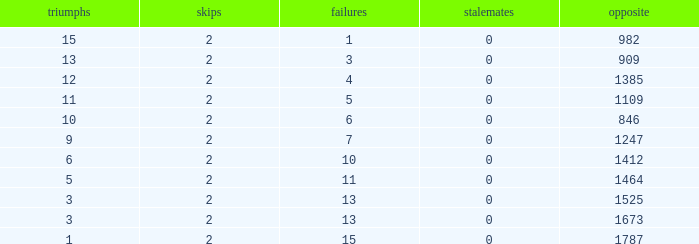What is the number listed under against when there were less than 13 losses and less than 2 byes? 0.0. Write the full table. {'header': ['triumphs', 'skips', 'failures', 'stalemates', 'opposite'], 'rows': [['15', '2', '1', '0', '982'], ['13', '2', '3', '0', '909'], ['12', '2', '4', '0', '1385'], ['11', '2', '5', '0', '1109'], ['10', '2', '6', '0', '846'], ['9', '2', '7', '0', '1247'], ['6', '2', '10', '0', '1412'], ['5', '2', '11', '0', '1464'], ['3', '2', '13', '0', '1525'], ['3', '2', '13', '0', '1673'], ['1', '2', '15', '0', '1787']]} 